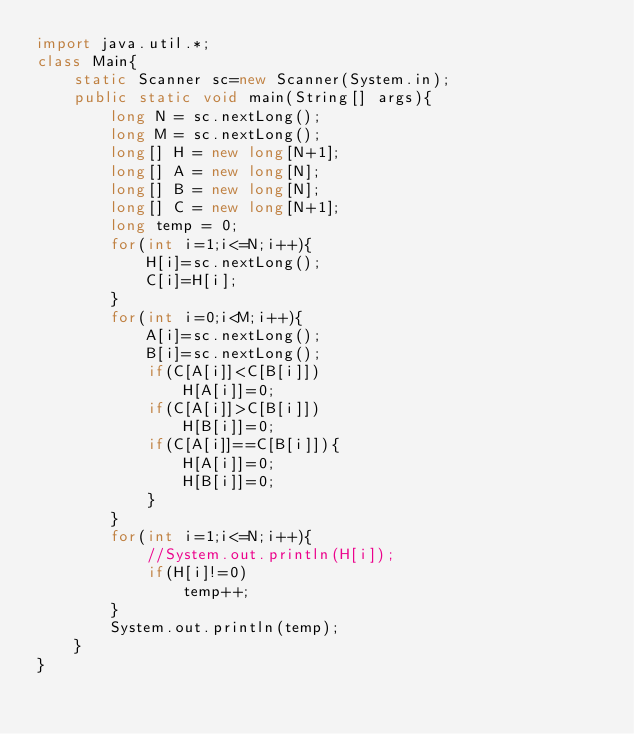Convert code to text. <code><loc_0><loc_0><loc_500><loc_500><_Java_>import java.util.*;
class Main{
    static Scanner sc=new Scanner(System.in);
    public static void main(String[] args){
        long N = sc.nextLong();
        long M = sc.nextLong();
        long[] H = new long[N+1];
        long[] A = new long[N];
        long[] B = new long[N];
        long[] C = new long[N+1];
        long temp = 0;
        for(int i=1;i<=N;i++){
            H[i]=sc.nextLong();
            C[i]=H[i];
        }
        for(int i=0;i<M;i++){
            A[i]=sc.nextLong();
            B[i]=sc.nextLong();
            if(C[A[i]]<C[B[i]])
                H[A[i]]=0;
            if(C[A[i]]>C[B[i]])
                H[B[i]]=0;
            if(C[A[i]]==C[B[i]]){
                H[A[i]]=0;
                H[B[i]]=0;
            }
        }
        for(int i=1;i<=N;i++){
            //System.out.println(H[i]);
            if(H[i]!=0)
                temp++;
        }
        System.out.println(temp);
    }
}</code> 